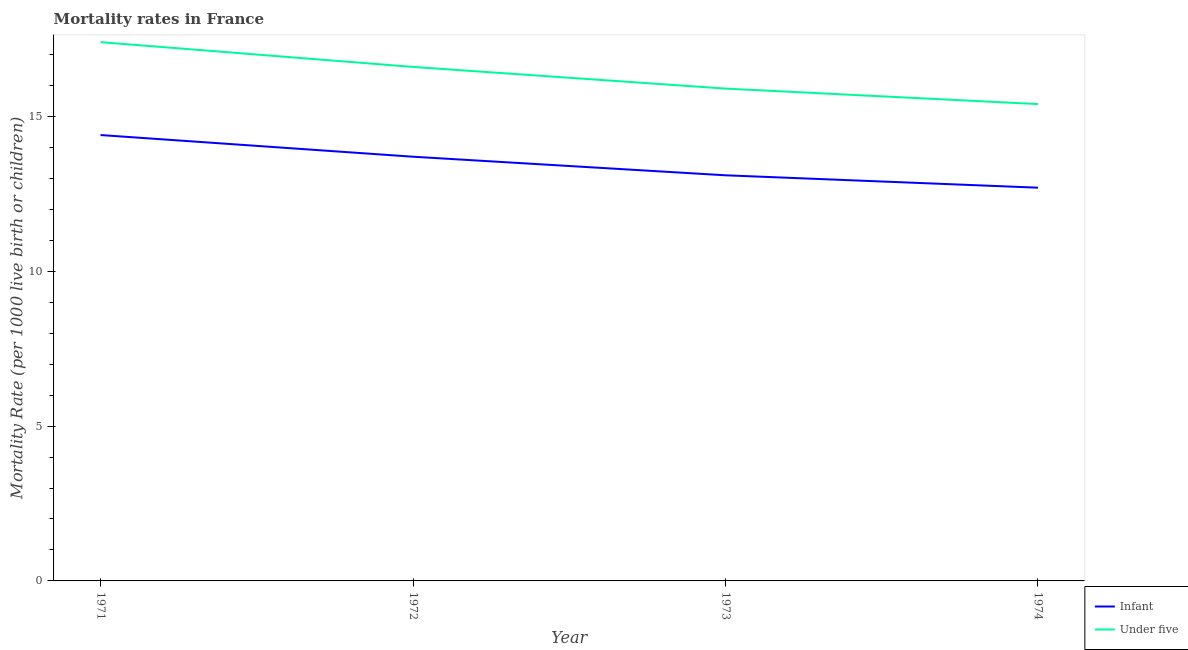How many different coloured lines are there?
Offer a terse response. 2. Does the line corresponding to infant mortality rate intersect with the line corresponding to under-5 mortality rate?
Your answer should be very brief. No. Is the number of lines equal to the number of legend labels?
Your response must be concise. Yes. Across all years, what is the maximum infant mortality rate?
Provide a short and direct response. 14.4. In which year was the under-5 mortality rate maximum?
Offer a very short reply. 1971. In which year was the infant mortality rate minimum?
Offer a very short reply. 1974. What is the total infant mortality rate in the graph?
Offer a very short reply. 53.9. What is the difference between the infant mortality rate in 1971 and that in 1972?
Provide a succinct answer. 0.7. What is the average infant mortality rate per year?
Give a very brief answer. 13.48. In the year 1974, what is the difference between the infant mortality rate and under-5 mortality rate?
Provide a short and direct response. -2.7. What is the ratio of the under-5 mortality rate in 1971 to that in 1972?
Keep it short and to the point. 1.05. Is the under-5 mortality rate in 1971 less than that in 1972?
Your answer should be compact. No. Is the difference between the infant mortality rate in 1971 and 1972 greater than the difference between the under-5 mortality rate in 1971 and 1972?
Ensure brevity in your answer.  No. What is the difference between the highest and the second highest under-5 mortality rate?
Offer a terse response. 0.8. What is the difference between the highest and the lowest under-5 mortality rate?
Keep it short and to the point. 2. In how many years, is the infant mortality rate greater than the average infant mortality rate taken over all years?
Your response must be concise. 2. Does the infant mortality rate monotonically increase over the years?
Keep it short and to the point. No. Is the infant mortality rate strictly greater than the under-5 mortality rate over the years?
Your answer should be very brief. No. Is the under-5 mortality rate strictly less than the infant mortality rate over the years?
Make the answer very short. No. How many lines are there?
Ensure brevity in your answer.  2. How many years are there in the graph?
Your answer should be very brief. 4. Are the values on the major ticks of Y-axis written in scientific E-notation?
Provide a short and direct response. No. How many legend labels are there?
Your answer should be very brief. 2. How are the legend labels stacked?
Provide a succinct answer. Vertical. What is the title of the graph?
Give a very brief answer. Mortality rates in France. Does "Methane" appear as one of the legend labels in the graph?
Ensure brevity in your answer.  No. What is the label or title of the Y-axis?
Your answer should be very brief. Mortality Rate (per 1000 live birth or children). What is the Mortality Rate (per 1000 live birth or children) of Under five in 1971?
Keep it short and to the point. 17.4. What is the Mortality Rate (per 1000 live birth or children) of Infant in 1972?
Provide a succinct answer. 13.7. Across all years, what is the maximum Mortality Rate (per 1000 live birth or children) of Infant?
Give a very brief answer. 14.4. Across all years, what is the maximum Mortality Rate (per 1000 live birth or children) of Under five?
Your answer should be compact. 17.4. Across all years, what is the minimum Mortality Rate (per 1000 live birth or children) in Under five?
Your answer should be compact. 15.4. What is the total Mortality Rate (per 1000 live birth or children) in Infant in the graph?
Give a very brief answer. 53.9. What is the total Mortality Rate (per 1000 live birth or children) in Under five in the graph?
Give a very brief answer. 65.3. What is the difference between the Mortality Rate (per 1000 live birth or children) in Under five in 1971 and that in 1972?
Offer a terse response. 0.8. What is the difference between the Mortality Rate (per 1000 live birth or children) in Under five in 1971 and that in 1973?
Your answer should be compact. 1.5. What is the difference between the Mortality Rate (per 1000 live birth or children) of Infant in 1971 and that in 1974?
Ensure brevity in your answer.  1.7. What is the difference between the Mortality Rate (per 1000 live birth or children) in Under five in 1971 and that in 1974?
Keep it short and to the point. 2. What is the difference between the Mortality Rate (per 1000 live birth or children) of Infant in 1972 and that in 1973?
Offer a terse response. 0.6. What is the difference between the Mortality Rate (per 1000 live birth or children) in Under five in 1972 and that in 1973?
Offer a very short reply. 0.7. What is the difference between the Mortality Rate (per 1000 live birth or children) of Infant in 1972 and that in 1974?
Your response must be concise. 1. What is the difference between the Mortality Rate (per 1000 live birth or children) in Under five in 1972 and that in 1974?
Offer a very short reply. 1.2. What is the difference between the Mortality Rate (per 1000 live birth or children) of Under five in 1973 and that in 1974?
Provide a short and direct response. 0.5. What is the difference between the Mortality Rate (per 1000 live birth or children) in Infant in 1972 and the Mortality Rate (per 1000 live birth or children) in Under five in 1974?
Your answer should be very brief. -1.7. What is the average Mortality Rate (per 1000 live birth or children) in Infant per year?
Keep it short and to the point. 13.47. What is the average Mortality Rate (per 1000 live birth or children) in Under five per year?
Your response must be concise. 16.32. In the year 1972, what is the difference between the Mortality Rate (per 1000 live birth or children) in Infant and Mortality Rate (per 1000 live birth or children) in Under five?
Your answer should be very brief. -2.9. What is the ratio of the Mortality Rate (per 1000 live birth or children) in Infant in 1971 to that in 1972?
Your answer should be very brief. 1.05. What is the ratio of the Mortality Rate (per 1000 live birth or children) in Under five in 1971 to that in 1972?
Make the answer very short. 1.05. What is the ratio of the Mortality Rate (per 1000 live birth or children) of Infant in 1971 to that in 1973?
Your response must be concise. 1.1. What is the ratio of the Mortality Rate (per 1000 live birth or children) of Under five in 1971 to that in 1973?
Make the answer very short. 1.09. What is the ratio of the Mortality Rate (per 1000 live birth or children) of Infant in 1971 to that in 1974?
Make the answer very short. 1.13. What is the ratio of the Mortality Rate (per 1000 live birth or children) in Under five in 1971 to that in 1974?
Give a very brief answer. 1.13. What is the ratio of the Mortality Rate (per 1000 live birth or children) of Infant in 1972 to that in 1973?
Your answer should be very brief. 1.05. What is the ratio of the Mortality Rate (per 1000 live birth or children) in Under five in 1972 to that in 1973?
Your response must be concise. 1.04. What is the ratio of the Mortality Rate (per 1000 live birth or children) of Infant in 1972 to that in 1974?
Ensure brevity in your answer.  1.08. What is the ratio of the Mortality Rate (per 1000 live birth or children) of Under five in 1972 to that in 1974?
Provide a short and direct response. 1.08. What is the ratio of the Mortality Rate (per 1000 live birth or children) of Infant in 1973 to that in 1974?
Give a very brief answer. 1.03. What is the ratio of the Mortality Rate (per 1000 live birth or children) of Under five in 1973 to that in 1974?
Make the answer very short. 1.03. What is the difference between the highest and the lowest Mortality Rate (per 1000 live birth or children) of Infant?
Your response must be concise. 1.7. 